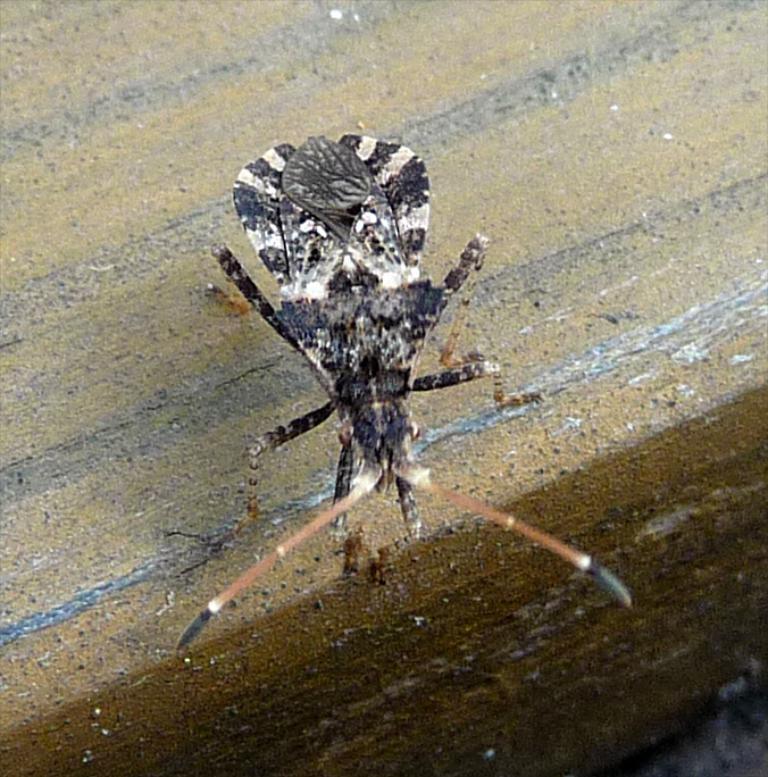Could you give a brief overview of what you see in this image? In the picture I can see a flying insect and it is looking like a wooden block. 